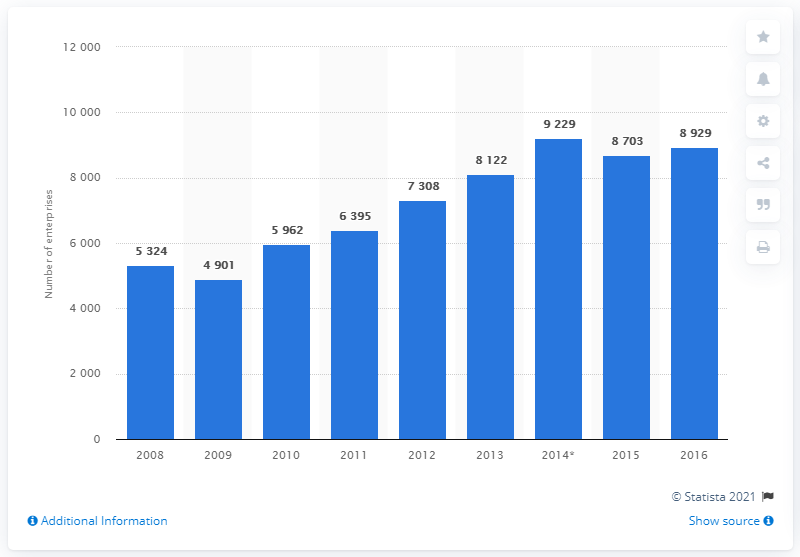List a handful of essential elements in this visual. In 2016, there were 8,929 travel agencies operating in France. 